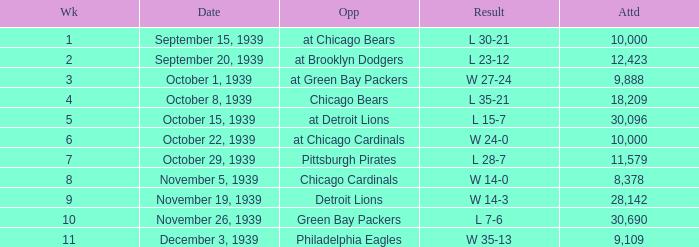What sum of Attendance has a Week smaller than 10, and a Result of l 30-21? 10000.0. 